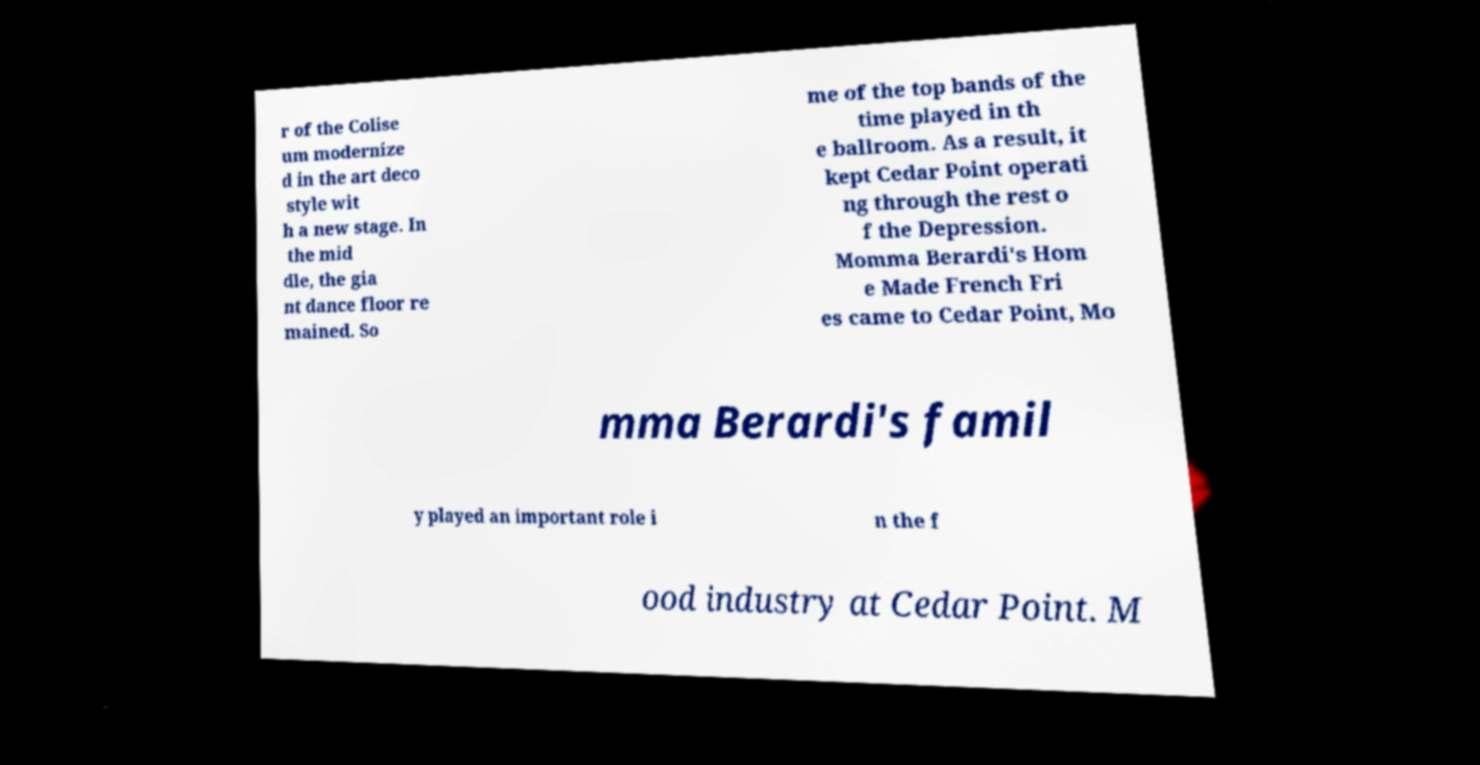Can you accurately transcribe the text from the provided image for me? r of the Colise um modernize d in the art deco style wit h a new stage. In the mid dle, the gia nt dance floor re mained. So me of the top bands of the time played in th e ballroom. As a result, it kept Cedar Point operati ng through the rest o f the Depression. Momma Berardi's Hom e Made French Fri es came to Cedar Point, Mo mma Berardi's famil y played an important role i n the f ood industry at Cedar Point. M 